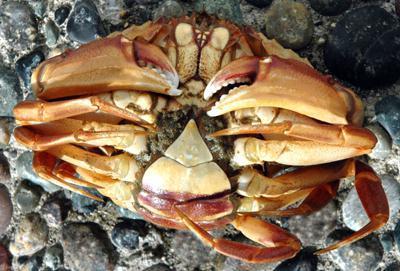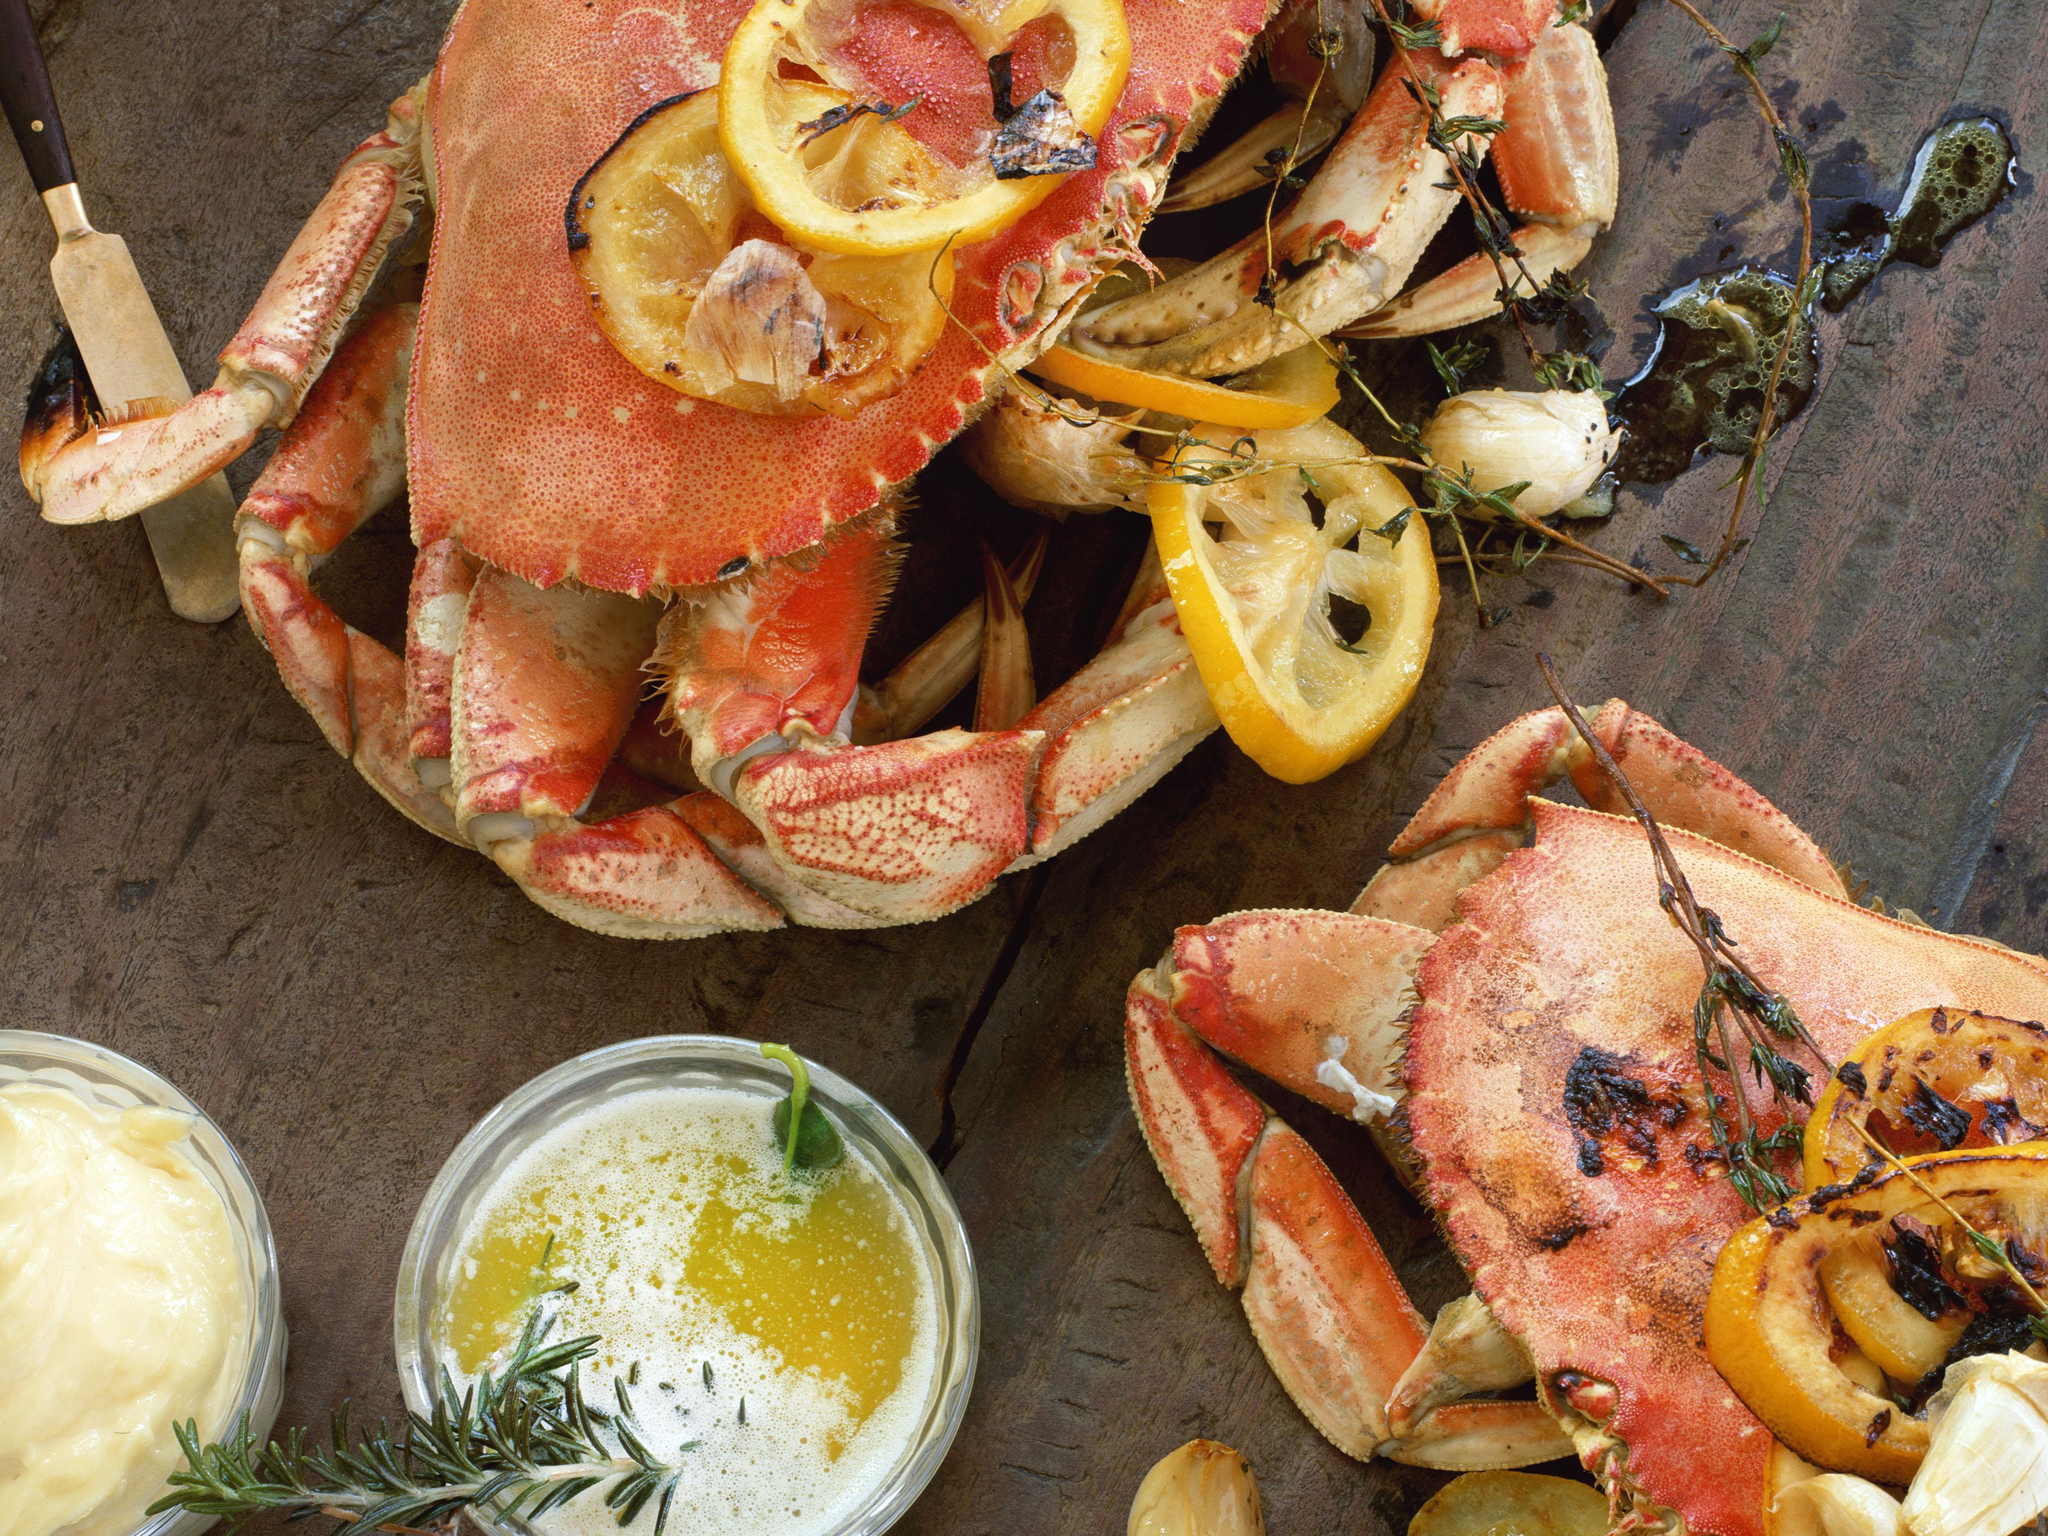The first image is the image on the left, the second image is the image on the right. Analyze the images presented: Is the assertion "There are more than three crabs." valid? Answer yes or no. No. The first image is the image on the left, the second image is the image on the right. Examine the images to the left and right. Is the description "One image shows the top of a reddish-orange crab, and the other image shows the bottom of at least one crab." accurate? Answer yes or no. Yes. 